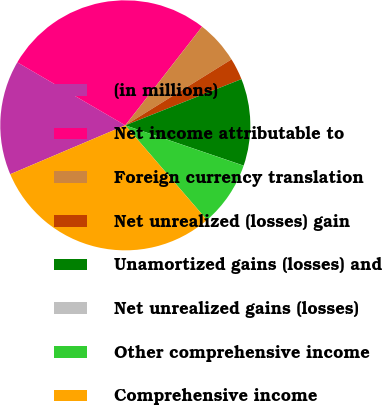Convert chart to OTSL. <chart><loc_0><loc_0><loc_500><loc_500><pie_chart><fcel>(in millions)<fcel>Net income attributable to<fcel>Foreign currency translation<fcel>Net unrealized (losses) gain<fcel>Unamortized gains (losses) and<fcel>Net unrealized gains (losses)<fcel>Other comprehensive income<fcel>Comprehensive income<nl><fcel>14.8%<fcel>27.12%<fcel>5.63%<fcel>2.82%<fcel>11.25%<fcel>0.01%<fcel>8.44%<fcel>29.93%<nl></chart> 